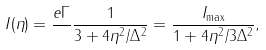Convert formula to latex. <formula><loc_0><loc_0><loc_500><loc_500>I ( \eta ) = \frac { e \Gamma } { } \frac { 1 } { 3 + 4 \eta ^ { 2 } / \Delta ^ { 2 } } = \frac { I _ { \max } } { 1 + 4 \eta ^ { 2 } / 3 \Delta ^ { 2 } } ,</formula> 